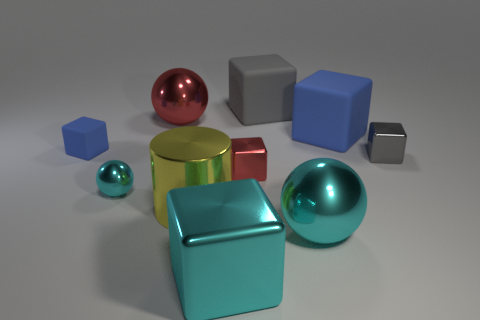What size is the blue cube left of the cyan metal sphere that is behind the cyan ball in front of the small metal sphere?
Keep it short and to the point. Small. What is the material of the big sphere that is the same color as the small metallic sphere?
Your answer should be very brief. Metal. How many objects are small red metallic blocks or large balls?
Your answer should be compact. 3. What is the size of the gray shiny object that is the same shape as the tiny red shiny thing?
Offer a terse response. Small. Is there any other thing that has the same size as the gray rubber block?
Make the answer very short. Yes. What number of other objects are the same color as the small metal ball?
Make the answer very short. 2. What number of cubes are large red metallic things or tiny things?
Provide a succinct answer. 3. There is a large rubber object that is behind the big shiny thing behind the gray metal object; what is its color?
Give a very brief answer. Gray. What is the shape of the gray metallic object?
Your answer should be compact. Cube. There is a cyan shiny ball on the left side of the red cube; is it the same size as the large shiny cylinder?
Your answer should be compact. No. 